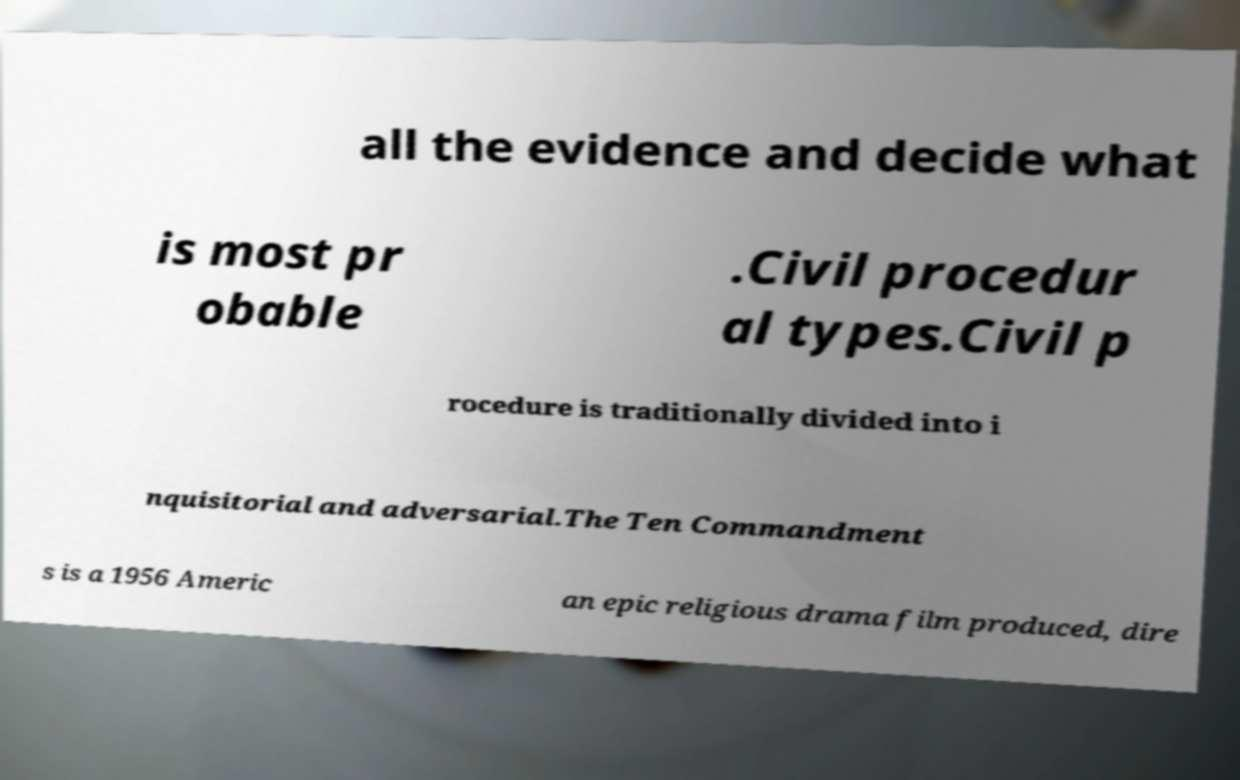There's text embedded in this image that I need extracted. Can you transcribe it verbatim? all the evidence and decide what is most pr obable .Civil procedur al types.Civil p rocedure is traditionally divided into i nquisitorial and adversarial.The Ten Commandment s is a 1956 Americ an epic religious drama film produced, dire 